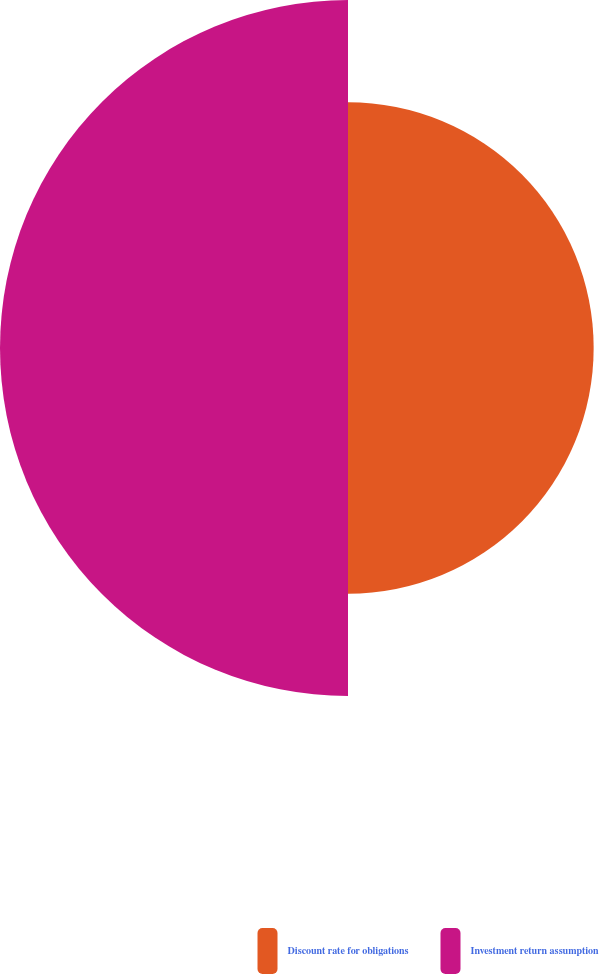Convert chart to OTSL. <chart><loc_0><loc_0><loc_500><loc_500><pie_chart><fcel>Discount rate for obligations<fcel>Investment return assumption<nl><fcel>41.38%<fcel>58.62%<nl></chart> 